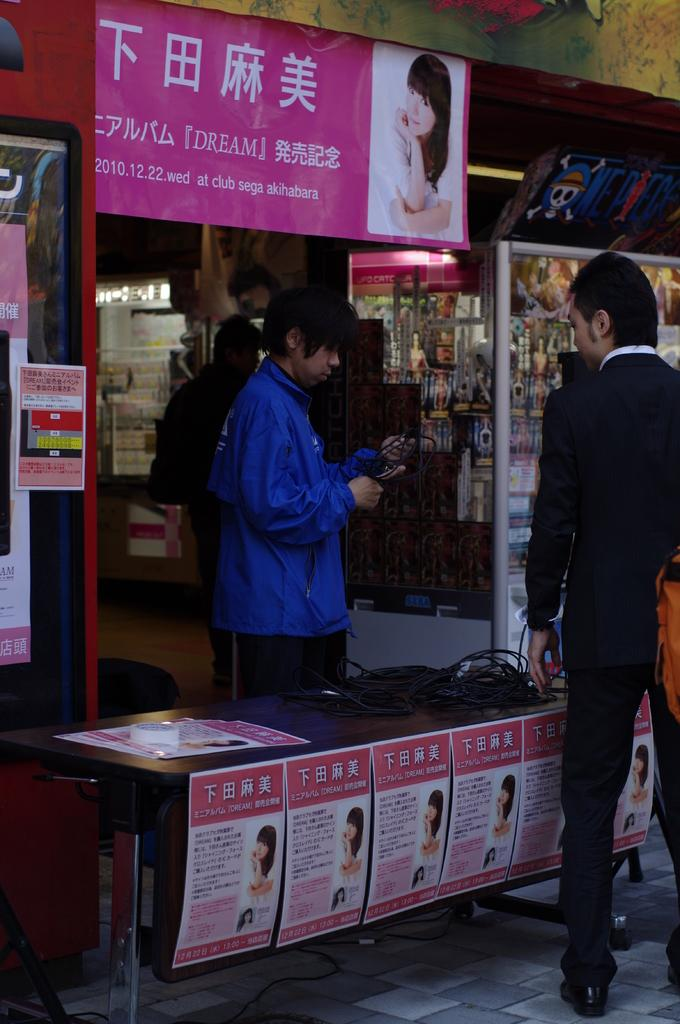What type of establishment is shown in the image? There is a shop in the image. How many people are present in the image? There are three persons standing in the image. What can be seen on the walls or windows of the shop? There are posters pasted in the image. How many dimes are scattered on the floor in the image? There are no dimes visible on the floor in the image. What type of cattle can be seen grazing in the background of the image? There is no background or cattle present in the image; it only shows a shop with three persons and posters. 